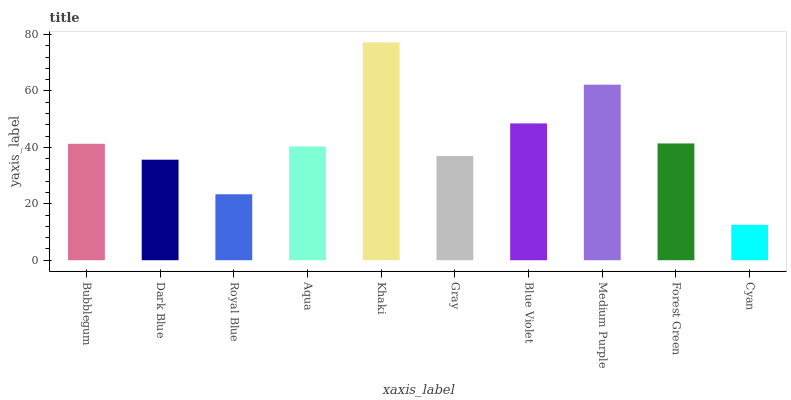Is Cyan the minimum?
Answer yes or no. Yes. Is Khaki the maximum?
Answer yes or no. Yes. Is Dark Blue the minimum?
Answer yes or no. No. Is Dark Blue the maximum?
Answer yes or no. No. Is Bubblegum greater than Dark Blue?
Answer yes or no. Yes. Is Dark Blue less than Bubblegum?
Answer yes or no. Yes. Is Dark Blue greater than Bubblegum?
Answer yes or no. No. Is Bubblegum less than Dark Blue?
Answer yes or no. No. Is Bubblegum the high median?
Answer yes or no. Yes. Is Aqua the low median?
Answer yes or no. Yes. Is Khaki the high median?
Answer yes or no. No. Is Cyan the low median?
Answer yes or no. No. 